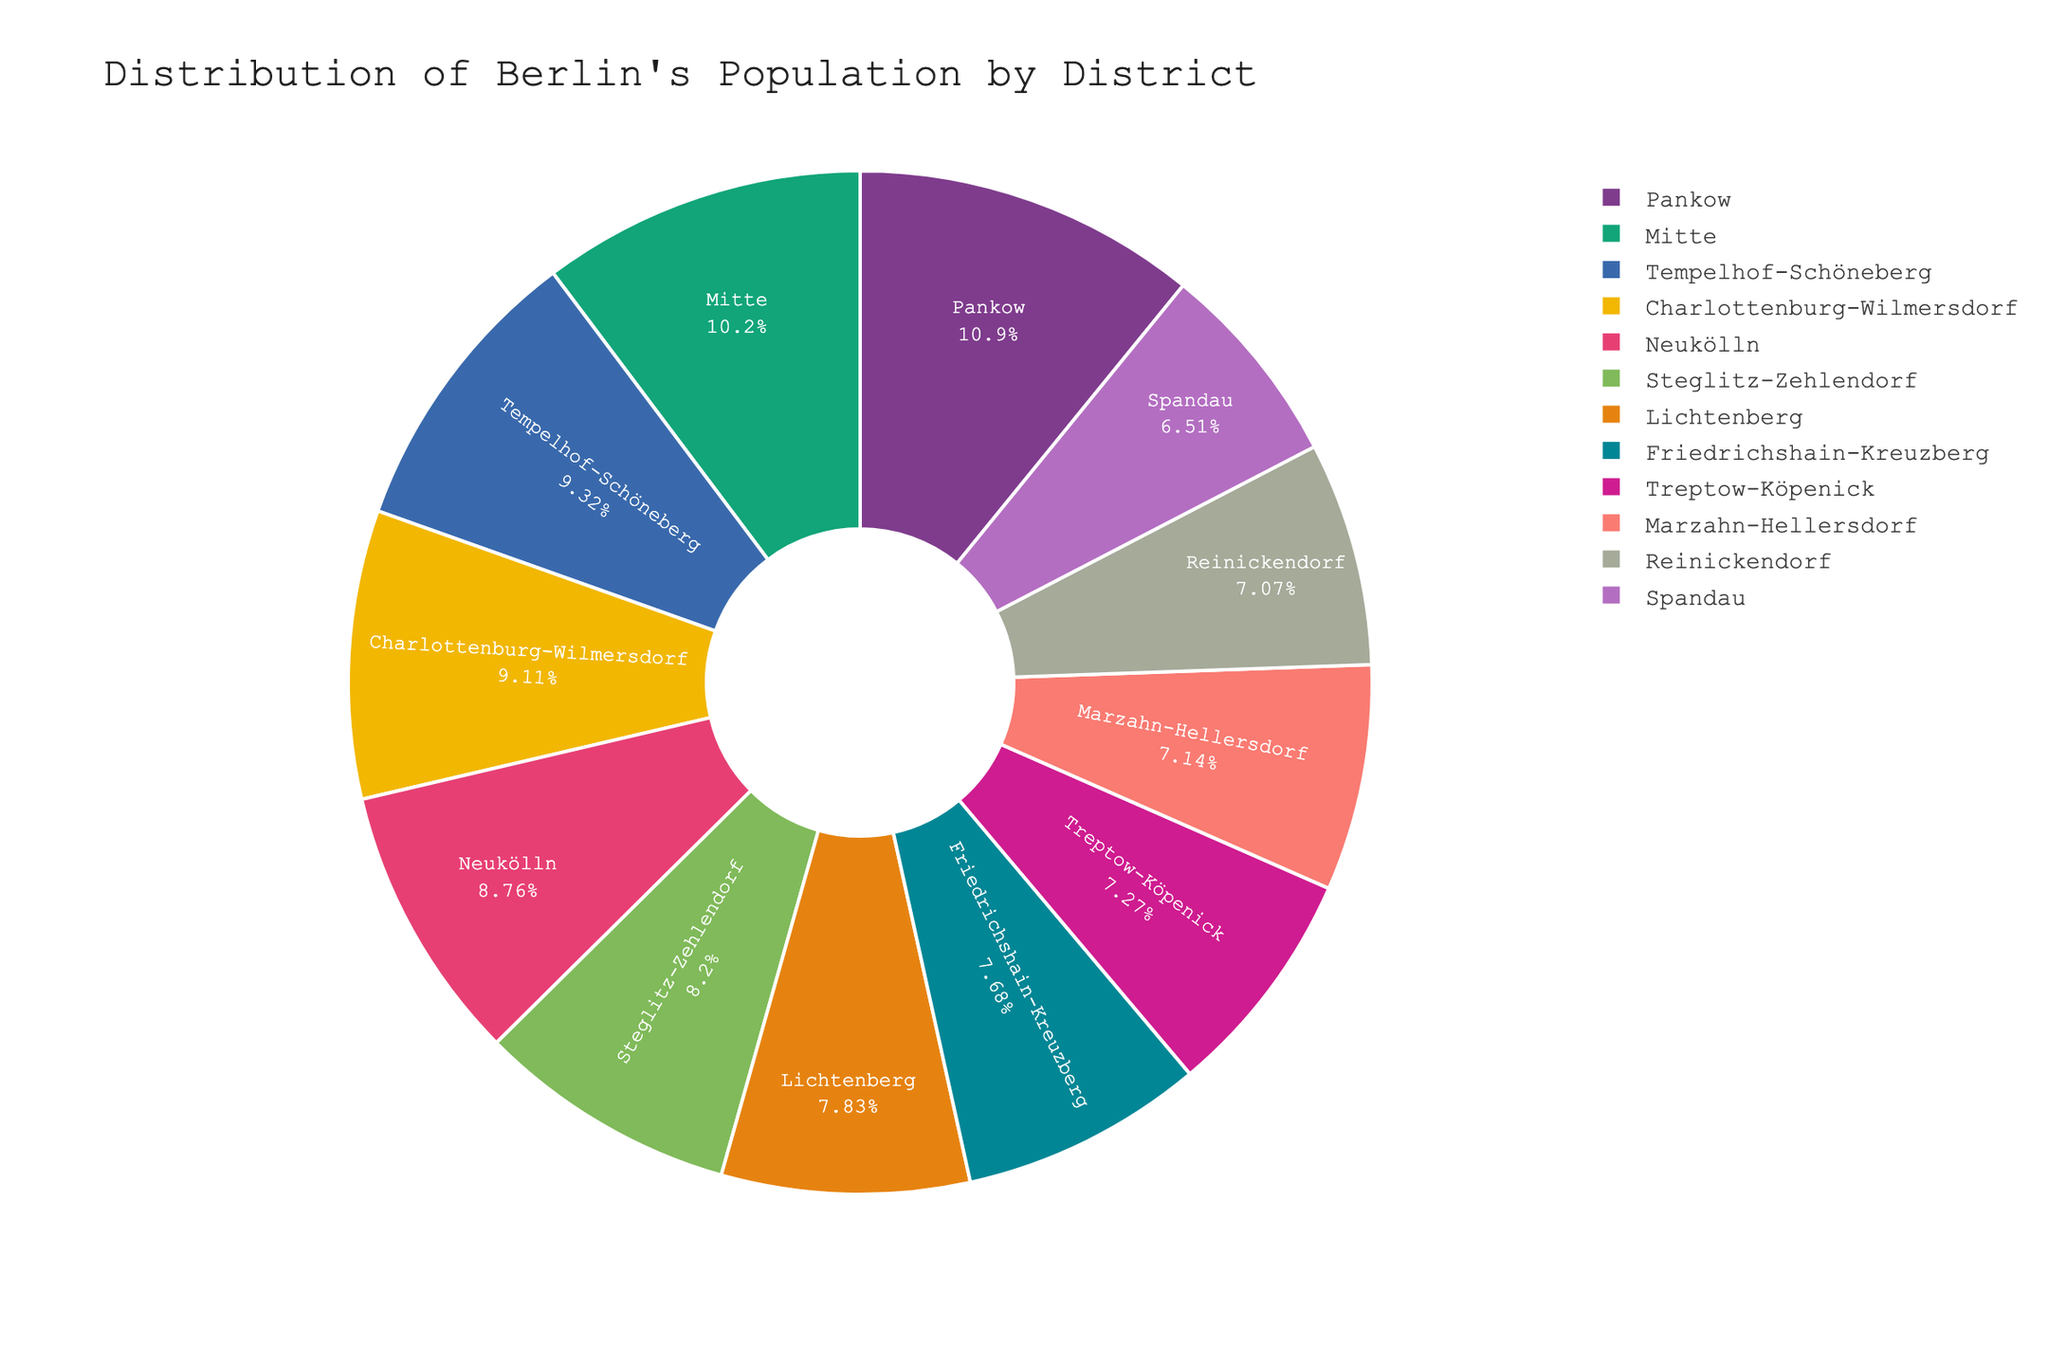what is the percentage of Berlin's population living in Mitte? Look at the pie chart segment labeled "Mitte" and read the percentage displayed inside.
Answer: % Which district has the highest population? Identify the largest segment in the pie chart, which represents the district with the highest population.
Answer: Pankow Which district has the smallest population? Identify the smallest segment in the pie chart, which represents the district with the smallest population.
Answer: Spandau How much larger is the population of Pankow compared to Spandau? Find the population numbers for Pankow and Spandau, take the difference: 409335 - 245197.
Answer: 164138 What is the combined population percentage of Mitte, Friedrichshain-Kreuzberg, and Pankow? Add the percentages displayed inside the "Mitte", "Friedrichshain-Kreuzberg", and "Pankow" segments in the pie chart.
Answer: % Is the population in Neukölln greater than in Lichtenberg? Compare the sizes of the segments labeled "Neukölln" and "Lichtenberg"; the larger one indicates a greater population.
Answer: Yes Place Charlottenburg-Wilmersdorf and Tempelhof-Schöneberg in order of population size, from largest to smallest. Compare the sizes of the segments for "Charlottenburg-Wilmersdorf" and "Tempelhof-Schöneberg"; order them by size.
Answer: Tempelhof-Schöneberg, Charlottenburg-Wilmersdorf What percentage of Berlin's population lives in districts with more than 300,000 people? Sum the percentages of districts whose population numbers exceed 300,000 (Mitte, Pankow, Charlottenburg-Wilmersdorf, Steglitz-Zehlendorf, Tempelhof-Schöneberg, Neukölln).
Answer: % What is the total population of Berlin based on this pie chart? Add all the population numbers together: 385748 + 289457 + 409335 + 342950 + 245197 + 308840 + 351062 + 329917 + 273817 + 269071 + 294937 + 266219.
Answer: 3765550 